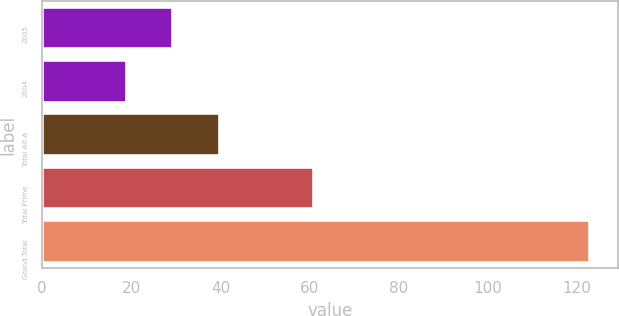Convert chart to OTSL. <chart><loc_0><loc_0><loc_500><loc_500><bar_chart><fcel>2005<fcel>2004<fcel>Total Alt-A<fcel>Total Prime<fcel>Grand Total<nl><fcel>29.4<fcel>19<fcel>39.8<fcel>61<fcel>123<nl></chart> 